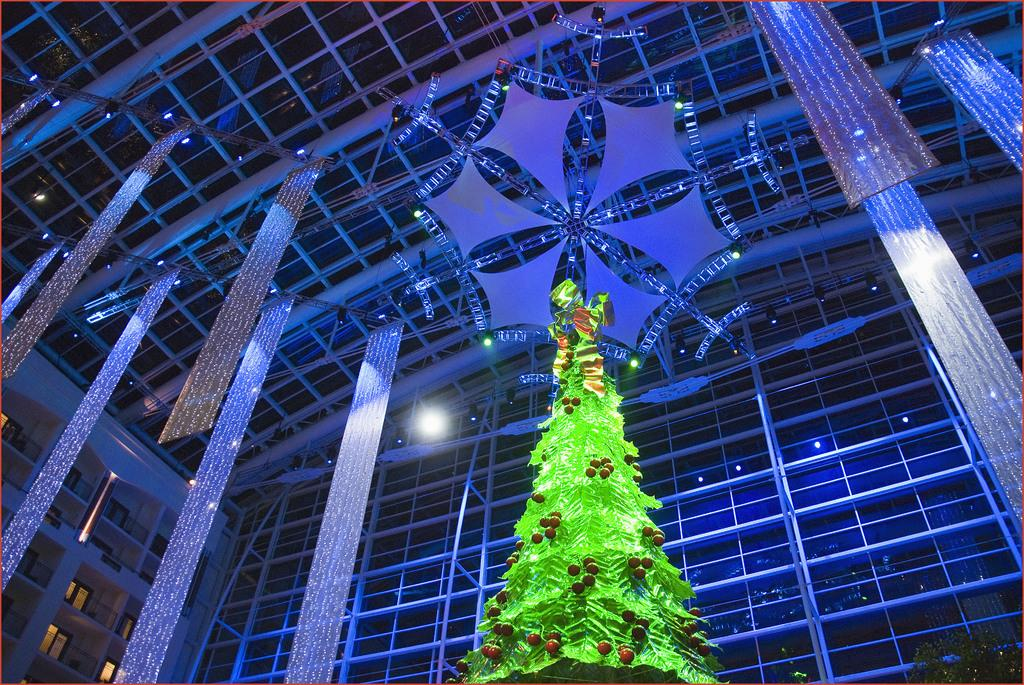What is the main subject in the center of the image? There is a Christmas tree in the middle of the image. Where is the Christmas tree located in relation to the other elements in the image? The Christmas tree is in the middle of the image. What can be seen in the background of the image? There is a glass wall and a roof in the background of the image. What type of wrench is being used to hang the Christmas tree in the image? There is no wrench present in the image, and the Christmas tree is not being hung; it is standing upright. 